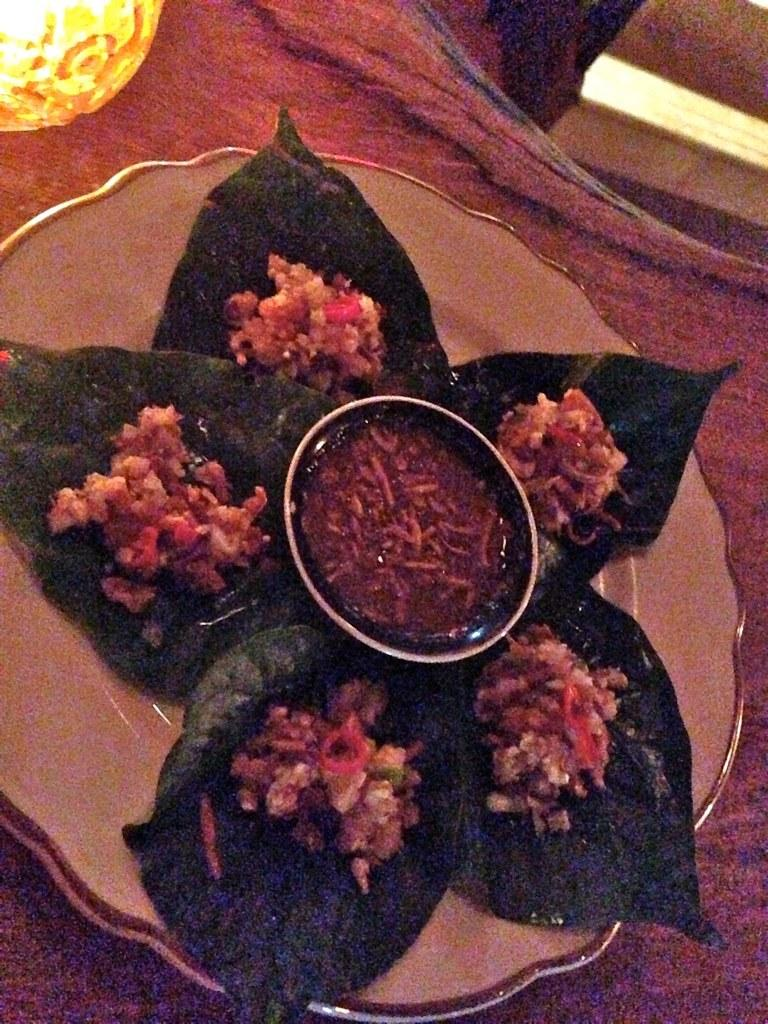What object is present on the plate in the image? There are leaves on the plate in the image. What else is on the plate besides the leaves? There is food placed on the plate. What can be seen at the bottom of the image? There is a cloth at the bottom of the image. What is the source of illumination in the image? There is a light in the image. How does the sock contribute to the overall aesthetic of the image? There is no sock present in the image, so it cannot contribute to the overall aesthetic. 